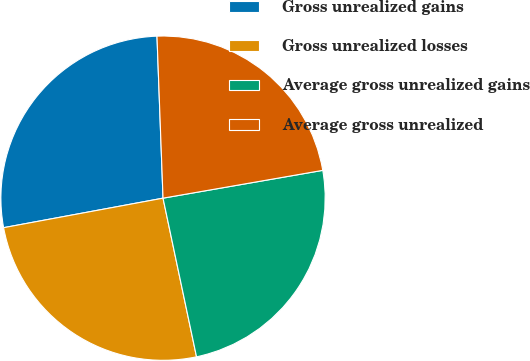Convert chart. <chart><loc_0><loc_0><loc_500><loc_500><pie_chart><fcel>Gross unrealized gains<fcel>Gross unrealized losses<fcel>Average gross unrealized gains<fcel>Average gross unrealized<nl><fcel>27.32%<fcel>25.4%<fcel>24.43%<fcel>22.85%<nl></chart> 